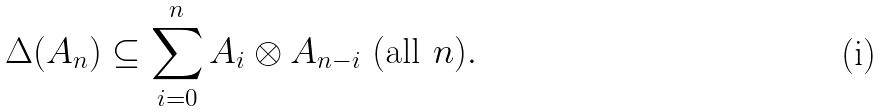Convert formula to latex. <formula><loc_0><loc_0><loc_500><loc_500>\Delta ( A _ { n } ) \subseteq \sum _ { i = 0 } ^ { n } A _ { i } \otimes A _ { n - i } \text { (all } n ) .</formula> 